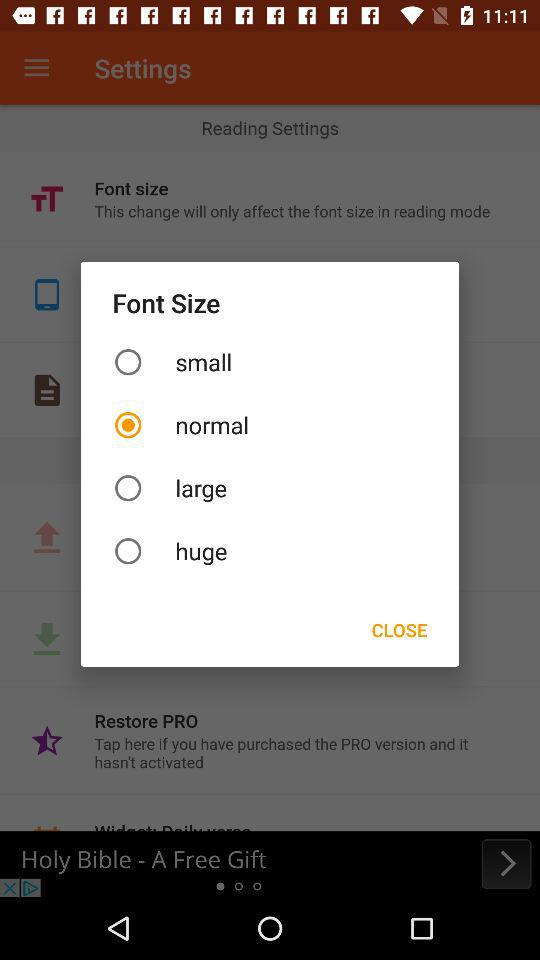What is the selected font size? The selected font size is normal. 